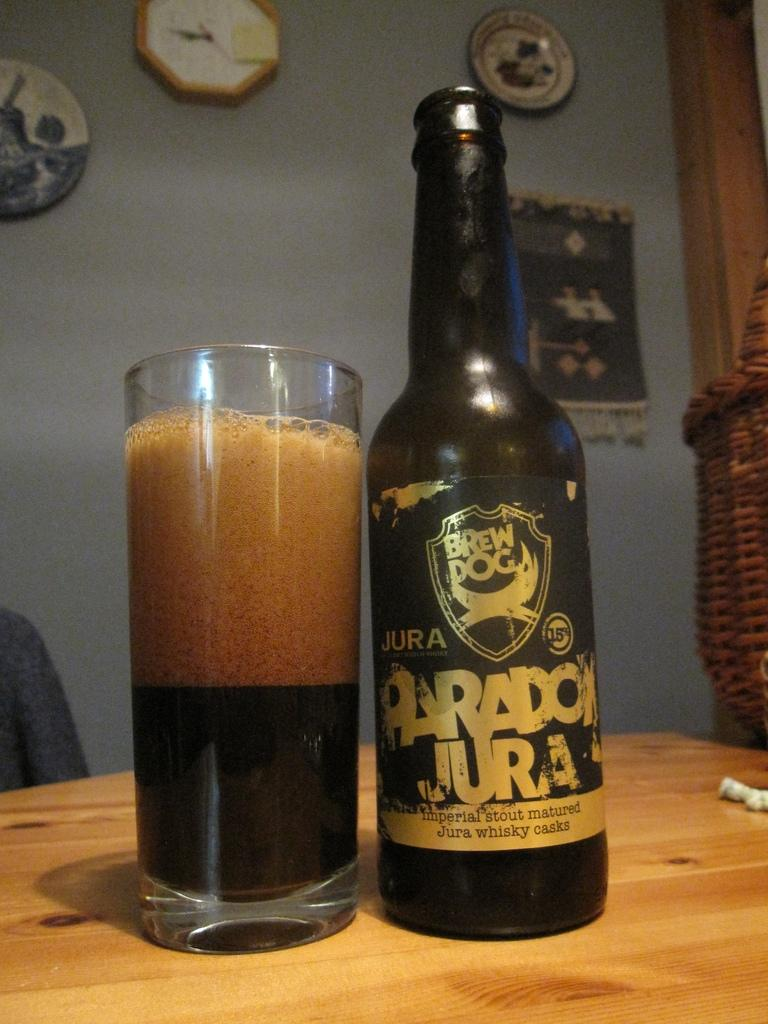<image>
Relay a brief, clear account of the picture shown. Glass of dark Jura Paradon beer sitting on a table. 